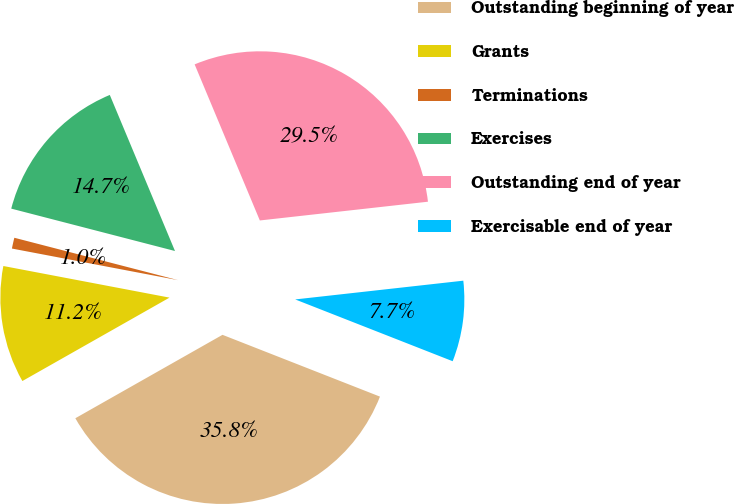Convert chart to OTSL. <chart><loc_0><loc_0><loc_500><loc_500><pie_chart><fcel>Outstanding beginning of year<fcel>Grants<fcel>Terminations<fcel>Exercises<fcel>Outstanding end of year<fcel>Exercisable end of year<nl><fcel>35.84%<fcel>11.2%<fcel>1.04%<fcel>14.67%<fcel>29.53%<fcel>7.72%<nl></chart> 